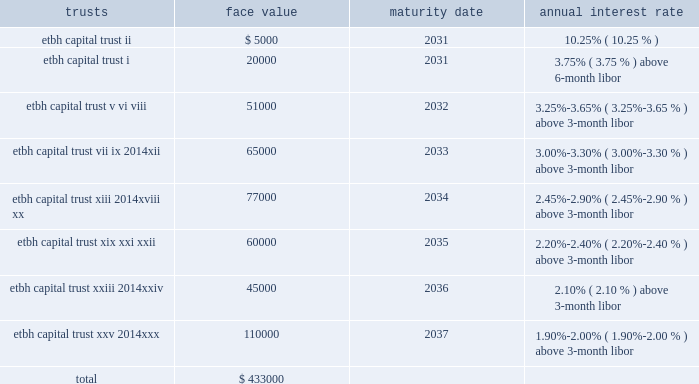Fhlb advances and other borrowings fhlb advances 2014the company had $ 0.7 billion in floating-rate and $ 0.2 billion in fixed-rate fhlb advances at both december 31 , 2013 and 2012 .
The floating-rate advances adjust quarterly based on the libor .
During the year ended december 31 , 2012 , $ 650.0 million of fixed-rate fhlb advances were converted to floating-rate for a total cost of approximately $ 128 million which was capitalized and will be amortized over the remaining maturities using the effective interest method .
In addition , during the year ended december 31 , 2012 , the company paid down in advance of maturity $ 1.0 billion of its fhlb advances and recorded $ 69.1 million in losses on the early extinguishment .
This loss was recorded in the gains ( losses ) on early extinguishment of debt line item in the consolidated statement of income ( loss ) .
The company did not have any similar transactions for the years ended december 31 , 2013 and 2011 .
As a condition of its membership in the fhlb atlanta , the company is required to maintain a fhlb stock investment currently equal to the lesser of : a percentage of 0.12% ( 0.12 % ) of total bank assets ; or a dollar cap amount of $ 20 million .
Additionally , the bank must maintain an activity based stock investment which is currently equal to 4.5% ( 4.5 % ) of the bank 2019s outstanding advances at the time of borrowing .
The company had an investment in fhlb stock of $ 61.4 million and $ 67.4 million at december 31 , 2013 and 2012 , respectively .
The company must also maintain qualified collateral as a percent of its advances , which varies based on the collateral type , and is further adjusted by the outcome of the most recent annual collateral audit and by fhlb 2019s internal ranking of the bank 2019s creditworthiness .
These advances are secured by a pool of mortgage loans and mortgage-backed securities .
At december 31 , 2013 and 2012 , the company pledged loans with a lendable value of $ 3.9 billion and $ 4.8 billion , respectively , of the one- to four-family and home equity loans as collateral in support of both its advances and unused borrowing lines .
Other borrowings 2014prior to 2008 , etbh raised capital through the formation of trusts , which sold trust preferred securities in the capital markets .
The capital securities must be redeemed in whole at the due date , which is generally 30 years after issuance .
Each trust issued floating rate cumulative preferred securities ( 201ctrust preferred securities 201d ) , at par with a liquidation amount of $ 1000 per capital security .
The trusts used the proceeds from the sale of issuances to purchase floating rate junior subordinated debentures ( 201csubordinated debentures 201d ) issued by etbh , which guarantees the trust obligations and contributed proceeds from the sale of its subordinated debentures to e*trade bank in the form of a capital contribution .
The most recent issuance of trust preferred securities occurred in 2007 .
The face values of outstanding trusts at december 31 , 2013 are shown below ( dollars in thousands ) : trusts face value maturity date annual interest rate .

At december 31 , 2013 what was the ratio of the face values of outstanding trusts 2037 maturities to the 2036? 
Rationale: at december 31 , 2013 there was 2.44 times face values of outstanding trusts 2037 maturities to the 2036
Computations: (110000 / 45000)
Answer: 2.44444. 